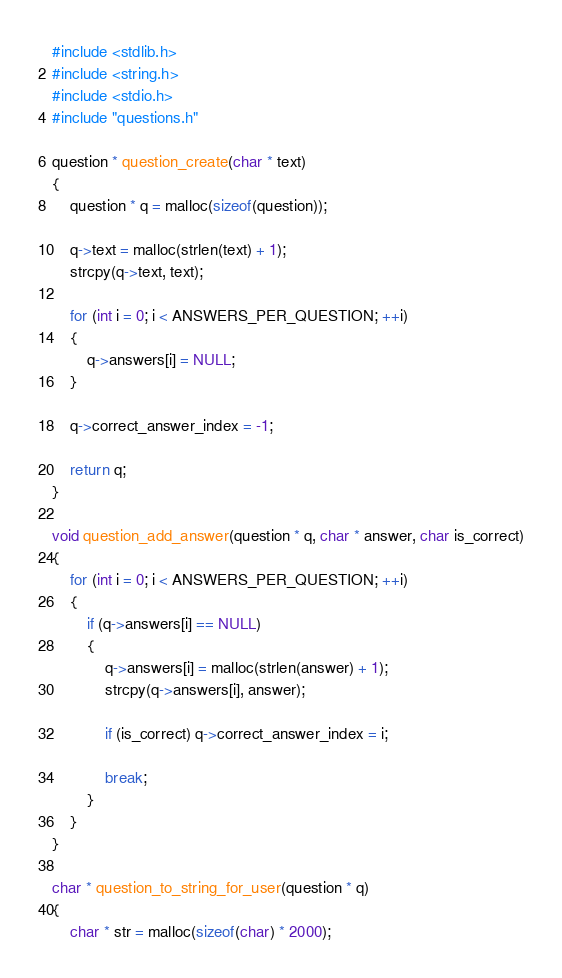<code> <loc_0><loc_0><loc_500><loc_500><_C_>#include <stdlib.h>
#include <string.h>
#include <stdio.h>
#include "questions.h"

question * question_create(char * text)
{
    question * q = malloc(sizeof(question));

    q->text = malloc(strlen(text) + 1);
    strcpy(q->text, text);

    for (int i = 0; i < ANSWERS_PER_QUESTION; ++i)
    {
        q->answers[i] = NULL;
    }

    q->correct_answer_index = -1;

    return q;
}

void question_add_answer(question * q, char * answer, char is_correct)
{
    for (int i = 0; i < ANSWERS_PER_QUESTION; ++i)
    {
        if (q->answers[i] == NULL)
        {
            q->answers[i] = malloc(strlen(answer) + 1);
            strcpy(q->answers[i], answer);

            if (is_correct) q->correct_answer_index = i;

            break;
        }
    }
}

char * question_to_string_for_user(question * q)
{
    char * str = malloc(sizeof(char) * 2000);
</code> 